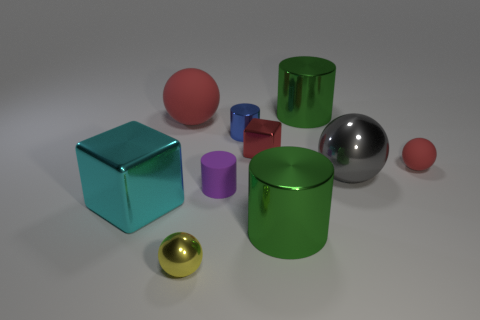There is a small metal thing that is in front of the large gray metallic thing; what is its shape?
Ensure brevity in your answer.  Sphere. Are there fewer big gray metallic objects on the left side of the small blue cylinder than tiny yellow metal balls that are to the right of the yellow shiny ball?
Make the answer very short. No. Does the blue metal object have the same size as the cyan metal cube left of the tiny block?
Offer a very short reply. No. How many gray metal balls are the same size as the purple object?
Provide a succinct answer. 0. There is a big ball that is made of the same material as the tiny red cube; what color is it?
Your answer should be compact. Gray. Is the number of yellow matte things greater than the number of big rubber things?
Provide a short and direct response. No. Are the big gray thing and the small blue thing made of the same material?
Make the answer very short. Yes. There is a tiny blue thing that is made of the same material as the cyan thing; what shape is it?
Your answer should be very brief. Cylinder. Are there fewer green rubber blocks than matte cylinders?
Ensure brevity in your answer.  Yes. The ball that is left of the large gray sphere and behind the gray shiny sphere is made of what material?
Your answer should be very brief. Rubber. 